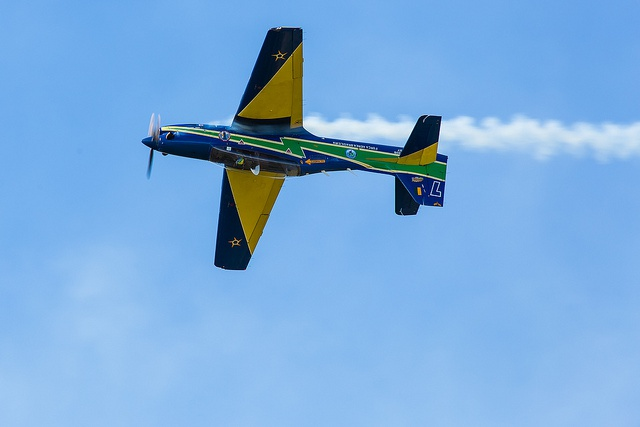Describe the objects in this image and their specific colors. I can see a airplane in lightblue, black, navy, and olive tones in this image. 